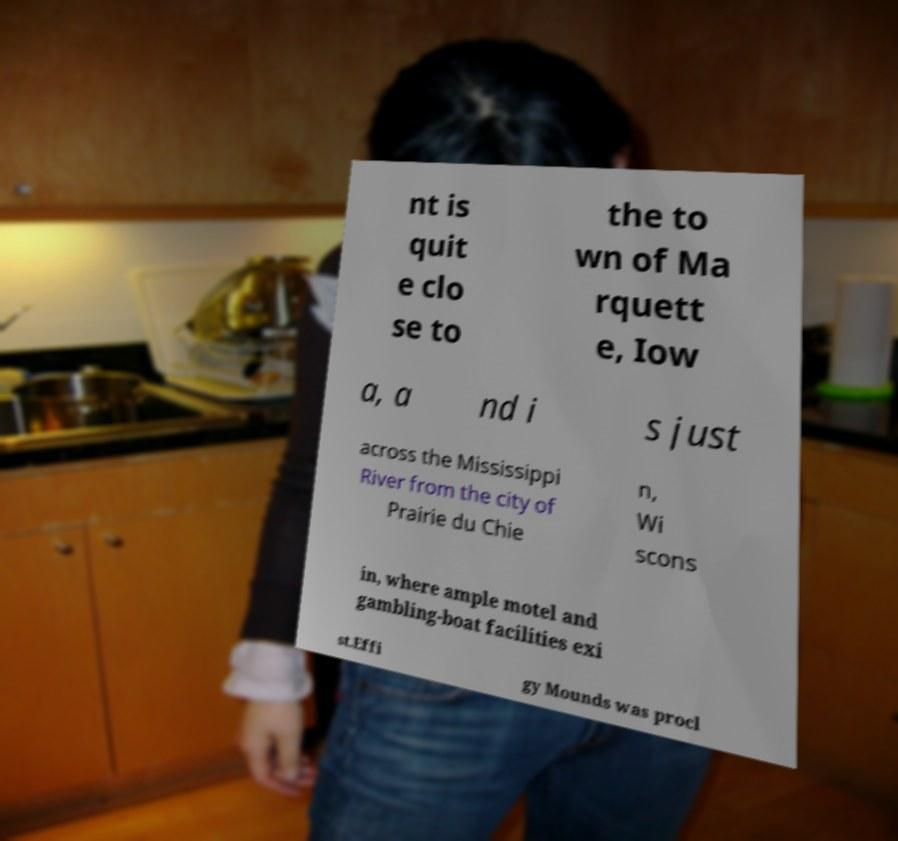Could you assist in decoding the text presented in this image and type it out clearly? nt is quit e clo se to the to wn of Ma rquett e, Iow a, a nd i s just across the Mississippi River from the city of Prairie du Chie n, Wi scons in, where ample motel and gambling-boat facilities exi st.Effi gy Mounds was procl 